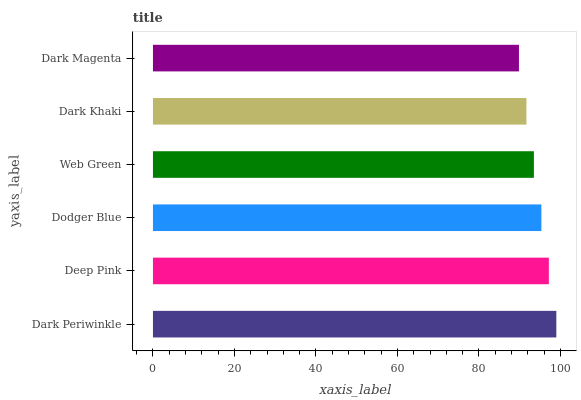Is Dark Magenta the minimum?
Answer yes or no. Yes. Is Dark Periwinkle the maximum?
Answer yes or no. Yes. Is Deep Pink the minimum?
Answer yes or no. No. Is Deep Pink the maximum?
Answer yes or no. No. Is Dark Periwinkle greater than Deep Pink?
Answer yes or no. Yes. Is Deep Pink less than Dark Periwinkle?
Answer yes or no. Yes. Is Deep Pink greater than Dark Periwinkle?
Answer yes or no. No. Is Dark Periwinkle less than Deep Pink?
Answer yes or no. No. Is Dodger Blue the high median?
Answer yes or no. Yes. Is Web Green the low median?
Answer yes or no. Yes. Is Dark Periwinkle the high median?
Answer yes or no. No. Is Dark Periwinkle the low median?
Answer yes or no. No. 